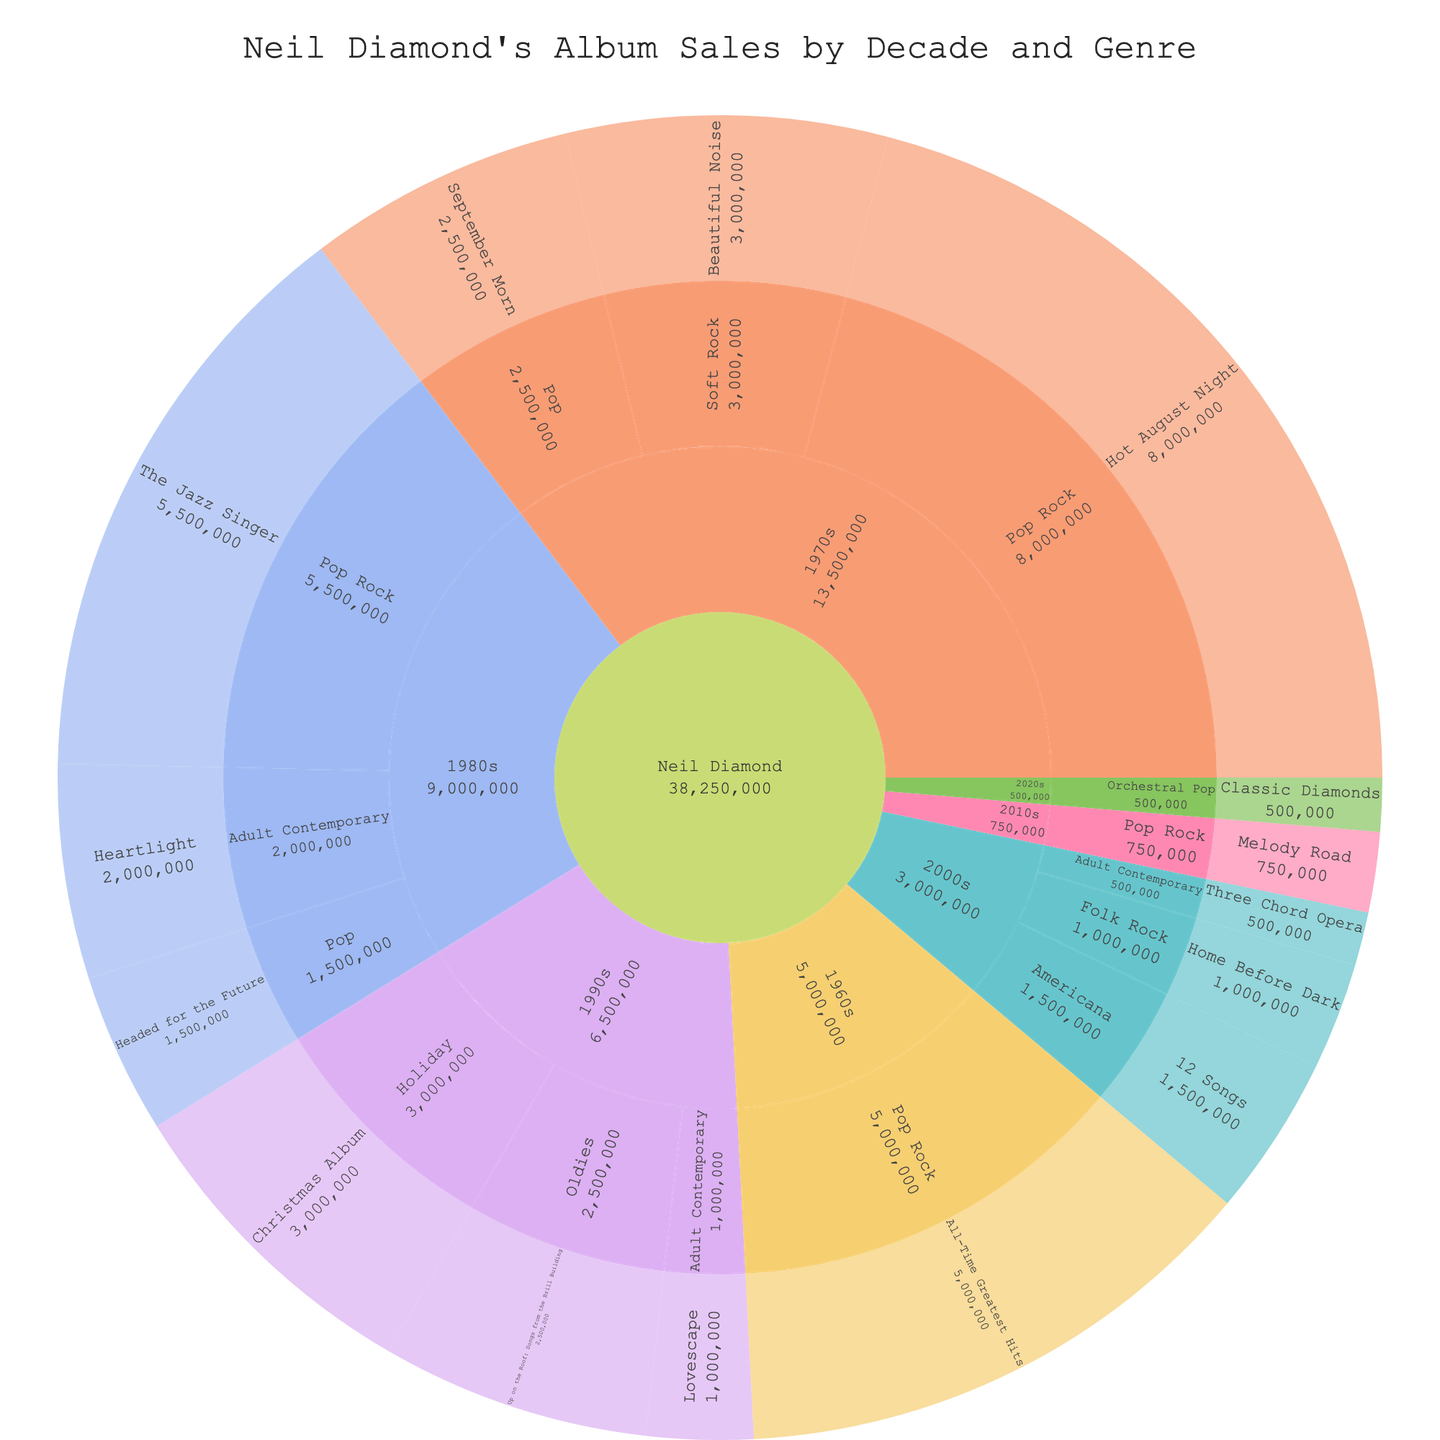What is the title of the plot? The title is typically displayed prominently at the top of the chart. Here, the title is used to describe the content of the figure.
Answer: Neil Diamond's Album Sales by Decade and Genre How many albums are represented in the 1980s? Look for the '1980s' section and count the number of albums within that part of the sunburst plot.
Answer: 3 Which genre had the highest album sales in the 1970s? Locate the '1970s' decade section and compare the sales of each genre within. The genre with the highest sales will be Pop Rock.
Answer: Pop Rock What is the total album sales for the 1990s? Sum up the sales figures for all albums listed under the '1990s' decade section (1000000 + 2500000 + 3000000).
Answer: 6500000 Which album had the highest sales overall? Identify the album segment with the largest sales value, regardless of the decade.
Answer: Hot August Night Between Pop Rock and Adult Contemporary, which genre had higher total album sales overall? Sum the sales of all albums under 'Pop Rock' and 'Adult Contemporary' respectively, then compare the totals. 
Pop Rock: 5000000 + 8000000 + 5500000 + 750000 = 19250000
Adult Contemporary: 2000000 + 1000000 + 500000 = 3500000
Answer: Pop Rock How do album sales in the 1980s compare to the 2000s? Sum total sales for albums in the '1980s' and '2000s' decade sections, then compare.
1980s: 5500000 + 2000000 + 1500000 = 9000000 
2000s: 500000 + 1500000 + 1000000 = 3000000
Answer: The 1980s had higher sales Which decade had the least album sales? Sum the sales for each decade and identify the decade with the smallest total.
1960s: 5000000
1970s: 8000000 + 3000000 + 2500000 = 13500000
1980s: 5500000 + 2000000 + 1500000 = 9000000
1990s: 1000000 + 2500000 + 3000000 = 6500000
2000s: 500000 + 1500000 + 1000000 = 3000000
2010s: 750000
2020s: 500000
Answer: 2020s What are the total album sales for the genres in the 2010s? Add up the sales figures for all albums in the '2010s' section, which only contains the 'Pop Rock' genre.
Answer: 750000 Which genre in the 2000s had the highest sales? Review the '2000s' section and compare sales of 'Adult Contemporary', 'Americana', and 'Folk Rock'.
Answer: Americana 